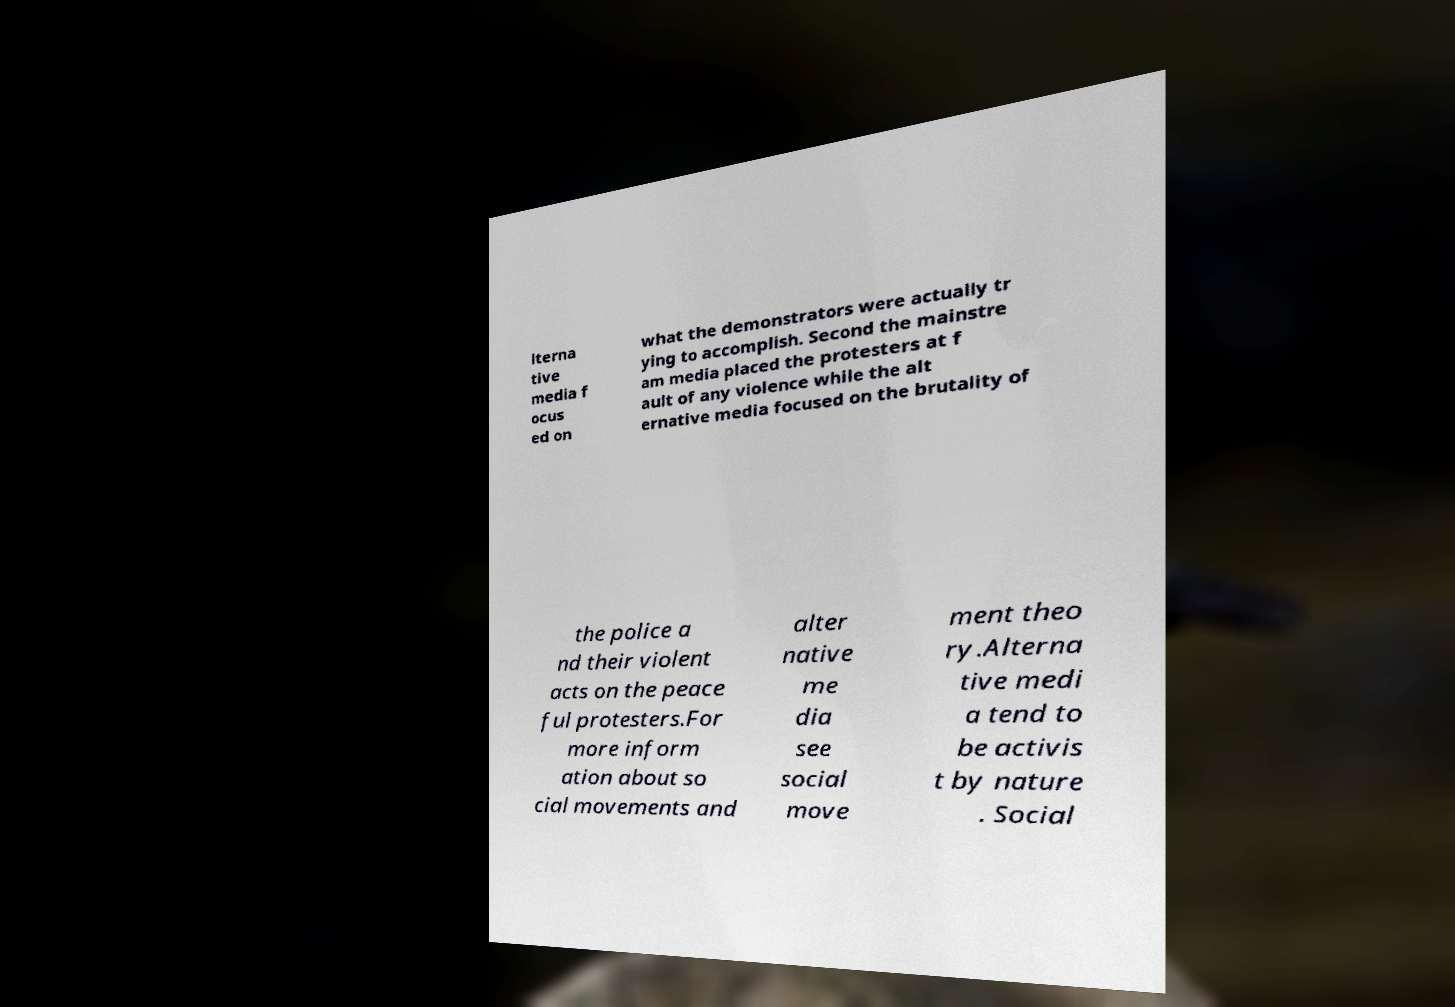Could you extract and type out the text from this image? lterna tive media f ocus ed on what the demonstrators were actually tr ying to accomplish. Second the mainstre am media placed the protesters at f ault of any violence while the alt ernative media focused on the brutality of the police a nd their violent acts on the peace ful protesters.For more inform ation about so cial movements and alter native me dia see social move ment theo ry.Alterna tive medi a tend to be activis t by nature . Social 